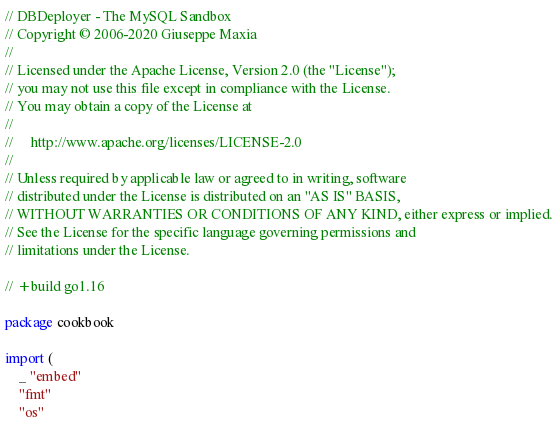<code> <loc_0><loc_0><loc_500><loc_500><_Go_>// DBDeployer - The MySQL Sandbox
// Copyright © 2006-2020 Giuseppe Maxia
//
// Licensed under the Apache License, Version 2.0 (the "License");
// you may not use this file except in compliance with the License.
// You may obtain a copy of the License at
//
//     http://www.apache.org/licenses/LICENSE-2.0
//
// Unless required by applicable law or agreed to in writing, software
// distributed under the License is distributed on an "AS IS" BASIS,
// WITHOUT WARRANTIES OR CONDITIONS OF ANY KIND, either express or implied.
// See the License for the specific language governing permissions and
// limitations under the License.

// +build go1.16

package cookbook

import (
	_ "embed"
	"fmt"
	"os"
</code> 